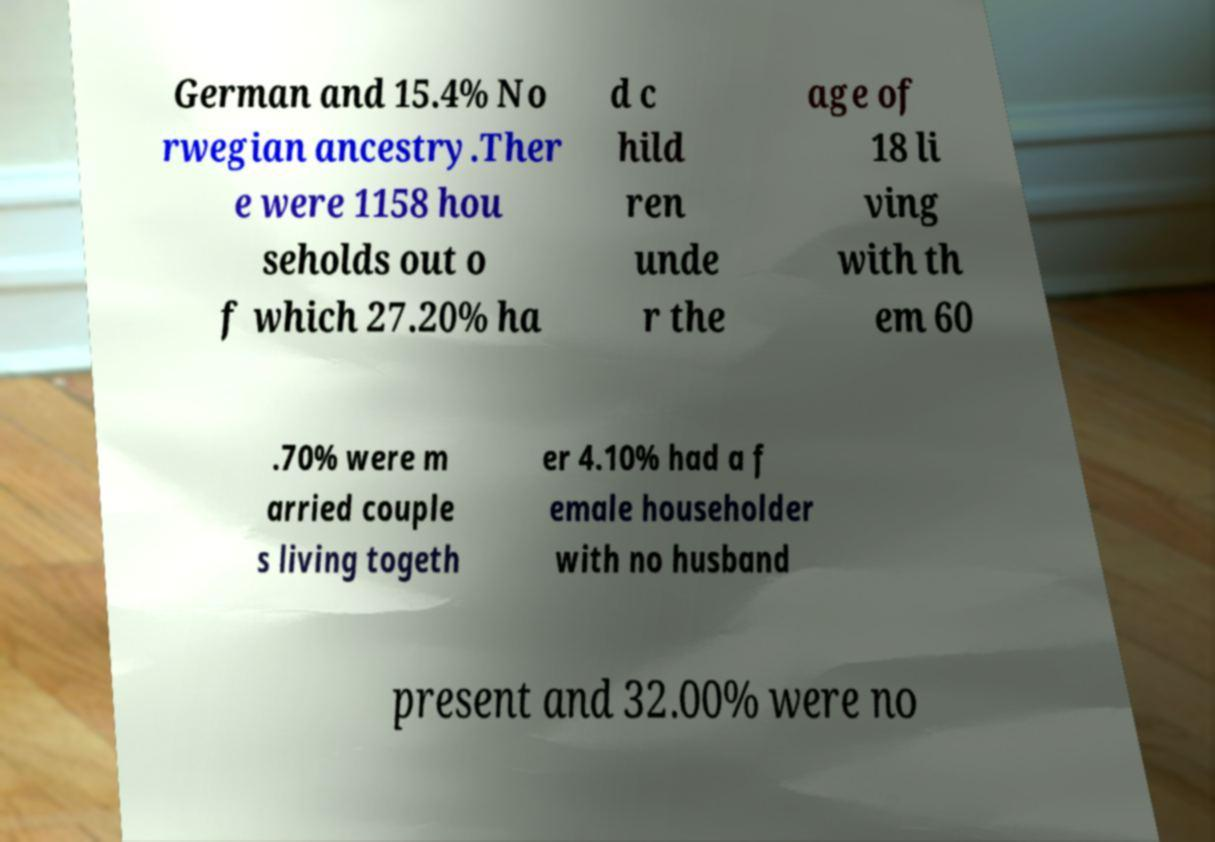Please identify and transcribe the text found in this image. German and 15.4% No rwegian ancestry.Ther e were 1158 hou seholds out o f which 27.20% ha d c hild ren unde r the age of 18 li ving with th em 60 .70% were m arried couple s living togeth er 4.10% had a f emale householder with no husband present and 32.00% were no 